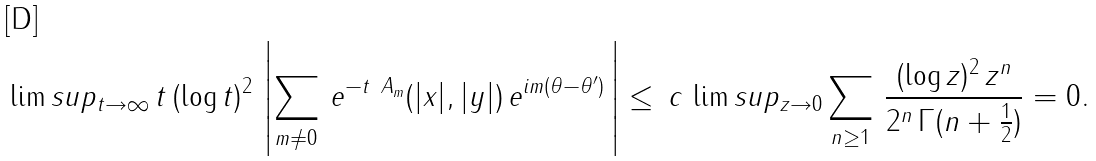Convert formula to latex. <formula><loc_0><loc_0><loc_500><loc_500>& \lim s u p _ { t \to \infty } \, t \, ( \log t ) ^ { 2 } \, \left | \sum _ { m \neq 0 } \, e ^ { - t \ A _ { m } } ( | x | , | y | ) \, e ^ { i m ( \theta - \theta ^ { \prime } ) } \, \right | \leq \, c \, \lim s u p _ { z \to 0 } \sum _ { n \geq 1 } \, \frac { ( \log z ) ^ { 2 } \, z ^ { n } } { 2 ^ { n } \, \Gamma ( n + \frac { 1 } { 2 } ) } = 0 .</formula> 